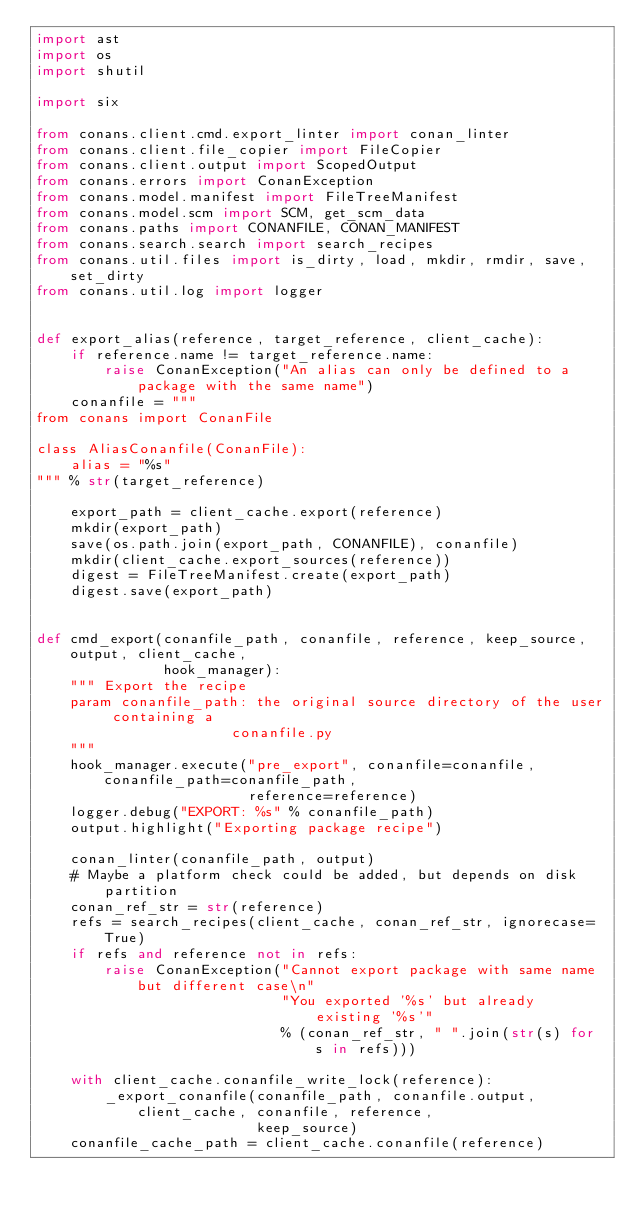<code> <loc_0><loc_0><loc_500><loc_500><_Python_>import ast
import os
import shutil

import six

from conans.client.cmd.export_linter import conan_linter
from conans.client.file_copier import FileCopier
from conans.client.output import ScopedOutput
from conans.errors import ConanException
from conans.model.manifest import FileTreeManifest
from conans.model.scm import SCM, get_scm_data
from conans.paths import CONANFILE, CONAN_MANIFEST
from conans.search.search import search_recipes
from conans.util.files import is_dirty, load, mkdir, rmdir, save, set_dirty
from conans.util.log import logger


def export_alias(reference, target_reference, client_cache):
    if reference.name != target_reference.name:
        raise ConanException("An alias can only be defined to a package with the same name")
    conanfile = """
from conans import ConanFile

class AliasConanfile(ConanFile):
    alias = "%s"
""" % str(target_reference)

    export_path = client_cache.export(reference)
    mkdir(export_path)
    save(os.path.join(export_path, CONANFILE), conanfile)
    mkdir(client_cache.export_sources(reference))
    digest = FileTreeManifest.create(export_path)
    digest.save(export_path)


def cmd_export(conanfile_path, conanfile, reference, keep_source, output, client_cache,
               hook_manager):
    """ Export the recipe
    param conanfile_path: the original source directory of the user containing a
                       conanfile.py
    """
    hook_manager.execute("pre_export", conanfile=conanfile, conanfile_path=conanfile_path,
                         reference=reference)
    logger.debug("EXPORT: %s" % conanfile_path)
    output.highlight("Exporting package recipe")

    conan_linter(conanfile_path, output)
    # Maybe a platform check could be added, but depends on disk partition
    conan_ref_str = str(reference)
    refs = search_recipes(client_cache, conan_ref_str, ignorecase=True)
    if refs and reference not in refs:
        raise ConanException("Cannot export package with same name but different case\n"
                             "You exported '%s' but already existing '%s'"
                             % (conan_ref_str, " ".join(str(s) for s in refs)))

    with client_cache.conanfile_write_lock(reference):
        _export_conanfile(conanfile_path, conanfile.output, client_cache, conanfile, reference,
                          keep_source)
    conanfile_cache_path = client_cache.conanfile(reference)</code> 